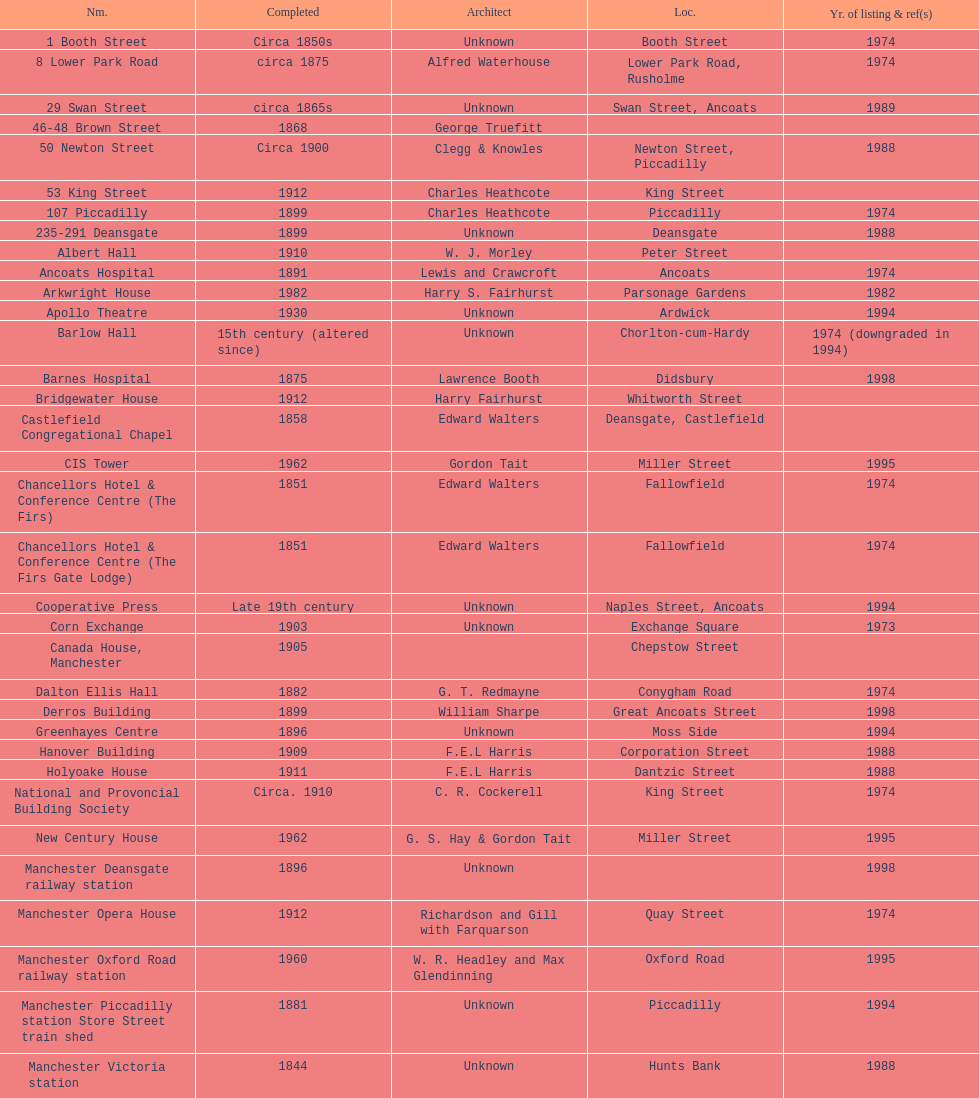How many buildings had alfred waterhouse as their architect? 3. 